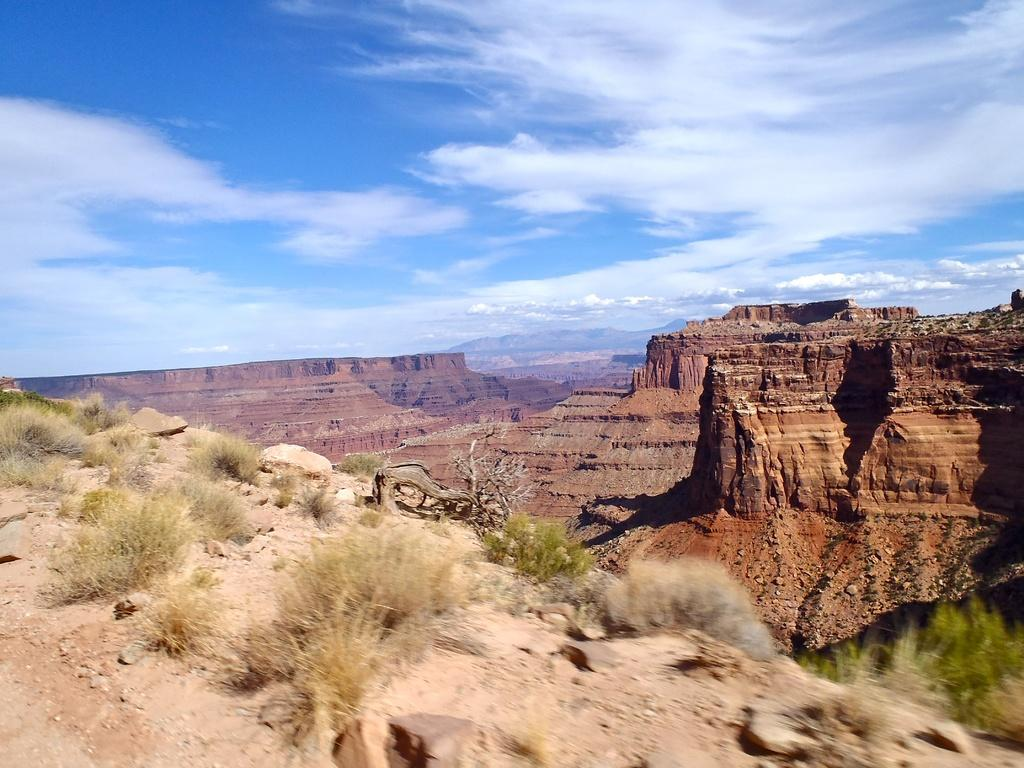What type of landscape is depicted in the image? There is a dry shrubland in the image. What can be seen in the background of the image? There are hills surrounding the shrubland in the image. Can you see a ship sailing through the shrubland in the image? No, there is no ship present in the image; it features a dry shrubland with surrounding hills. 